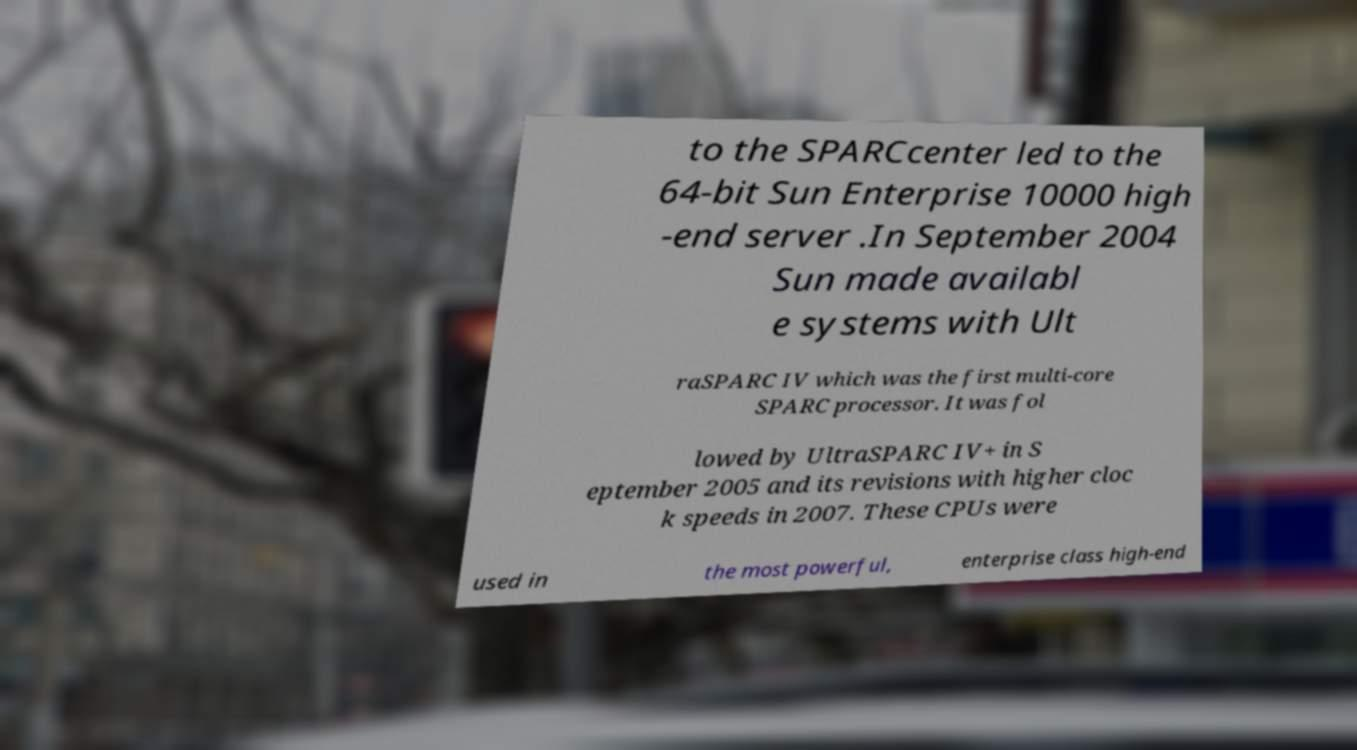Could you extract and type out the text from this image? to the SPARCcenter led to the 64-bit Sun Enterprise 10000 high -end server .In September 2004 Sun made availabl e systems with Ult raSPARC IV which was the first multi-core SPARC processor. It was fol lowed by UltraSPARC IV+ in S eptember 2005 and its revisions with higher cloc k speeds in 2007. These CPUs were used in the most powerful, enterprise class high-end 